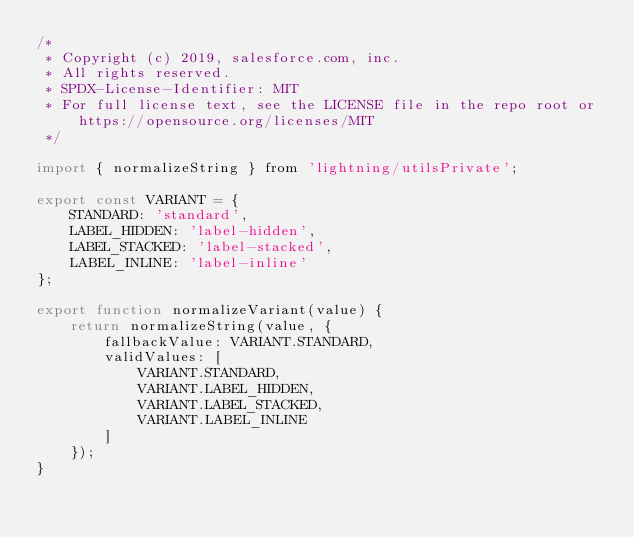<code> <loc_0><loc_0><loc_500><loc_500><_JavaScript_>/*
 * Copyright (c) 2019, salesforce.com, inc.
 * All rights reserved.
 * SPDX-License-Identifier: MIT
 * For full license text, see the LICENSE file in the repo root or https://opensource.org/licenses/MIT
 */

import { normalizeString } from 'lightning/utilsPrivate';

export const VARIANT = {
    STANDARD: 'standard',
    LABEL_HIDDEN: 'label-hidden',
    LABEL_STACKED: 'label-stacked',
    LABEL_INLINE: 'label-inline'
};

export function normalizeVariant(value) {
    return normalizeString(value, {
        fallbackValue: VARIANT.STANDARD,
        validValues: [
            VARIANT.STANDARD,
            VARIANT.LABEL_HIDDEN,
            VARIANT.LABEL_STACKED,
            VARIANT.LABEL_INLINE
        ]
    });
}
</code> 